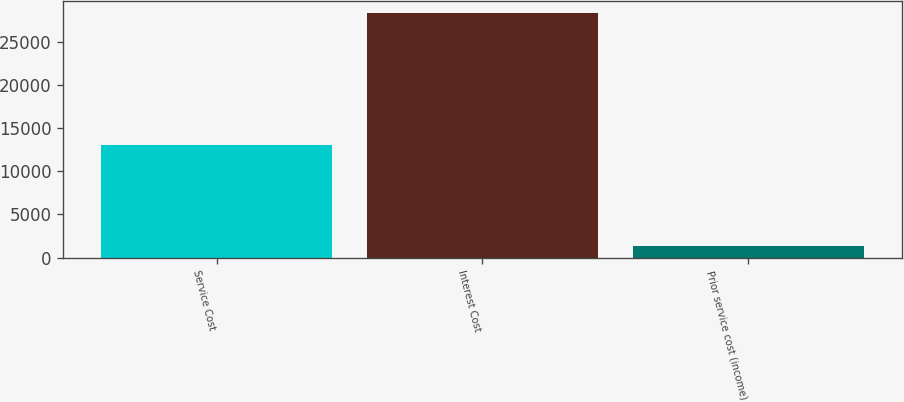<chart> <loc_0><loc_0><loc_500><loc_500><bar_chart><fcel>Service Cost<fcel>Interest Cost<fcel>Prior service cost (income)<nl><fcel>13042<fcel>28337<fcel>1343<nl></chart> 